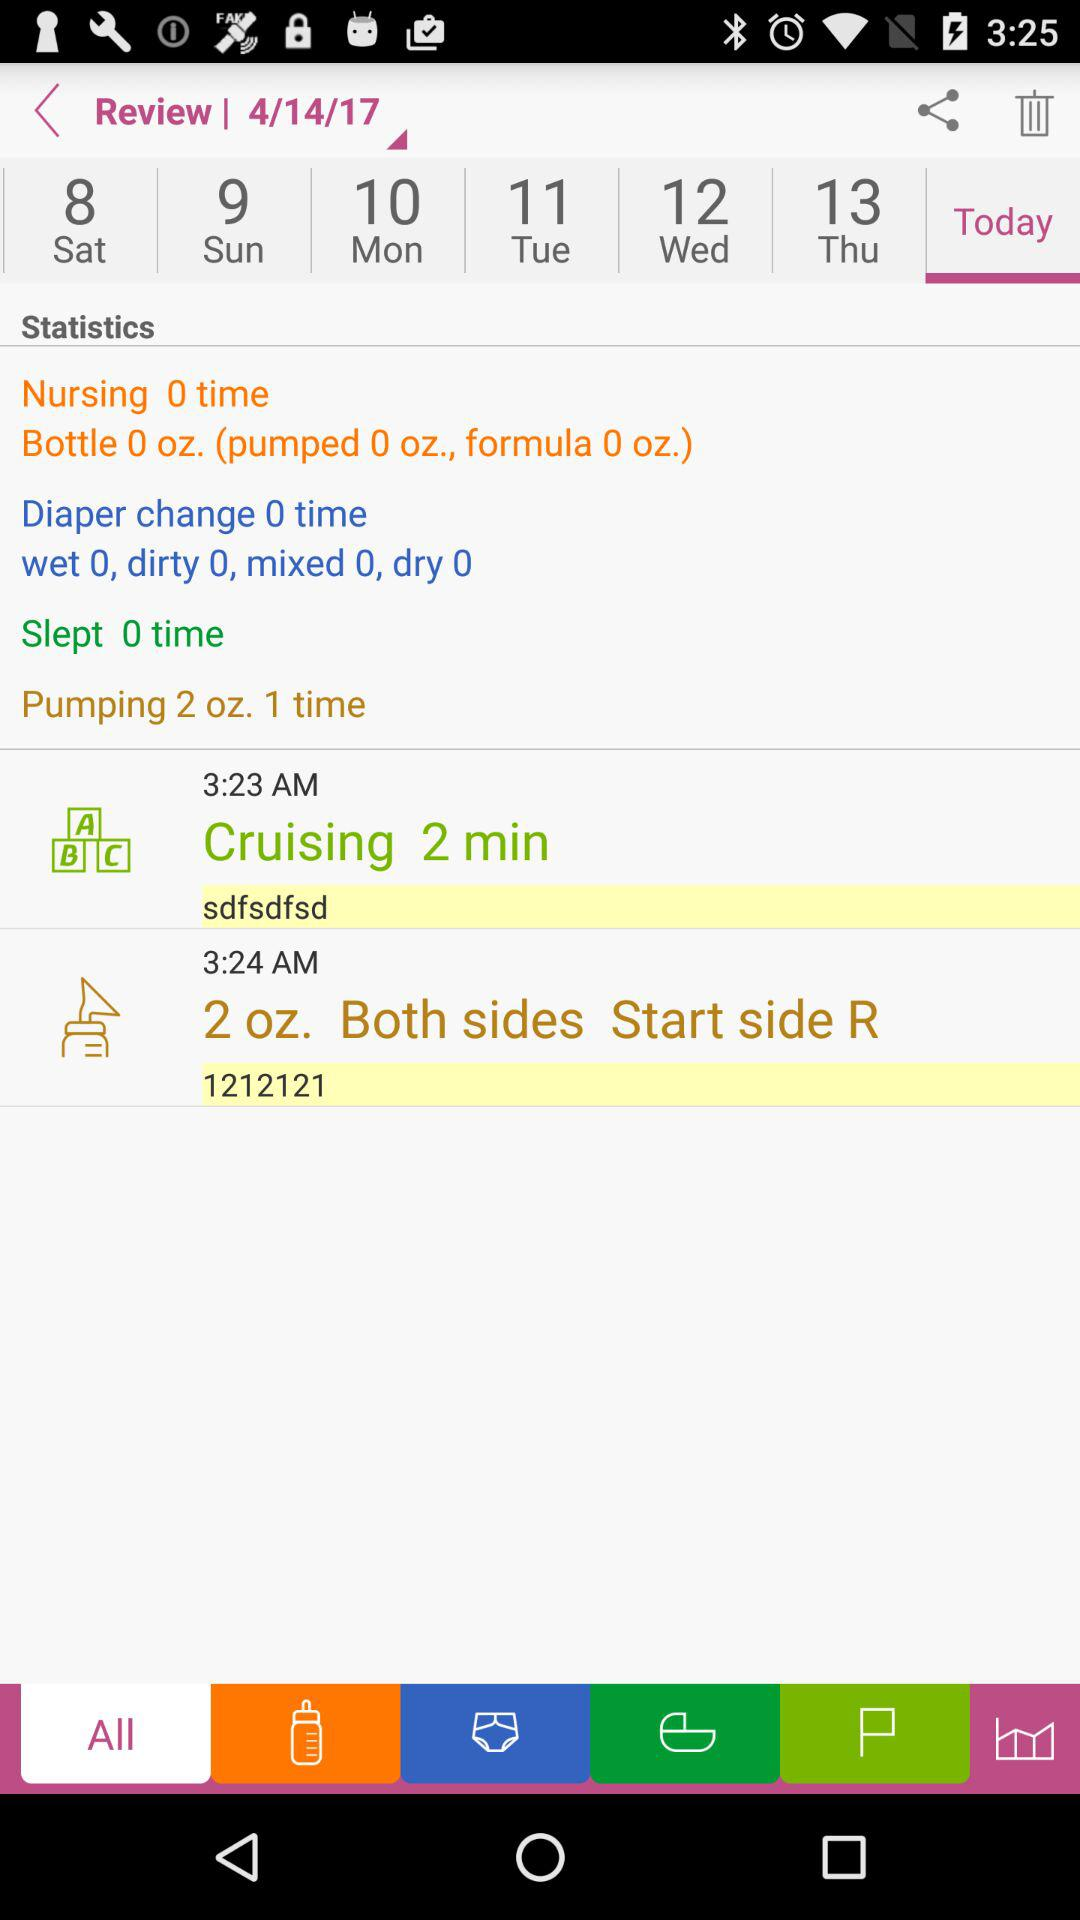What is today's date? Today's date is April 14, 2017. 